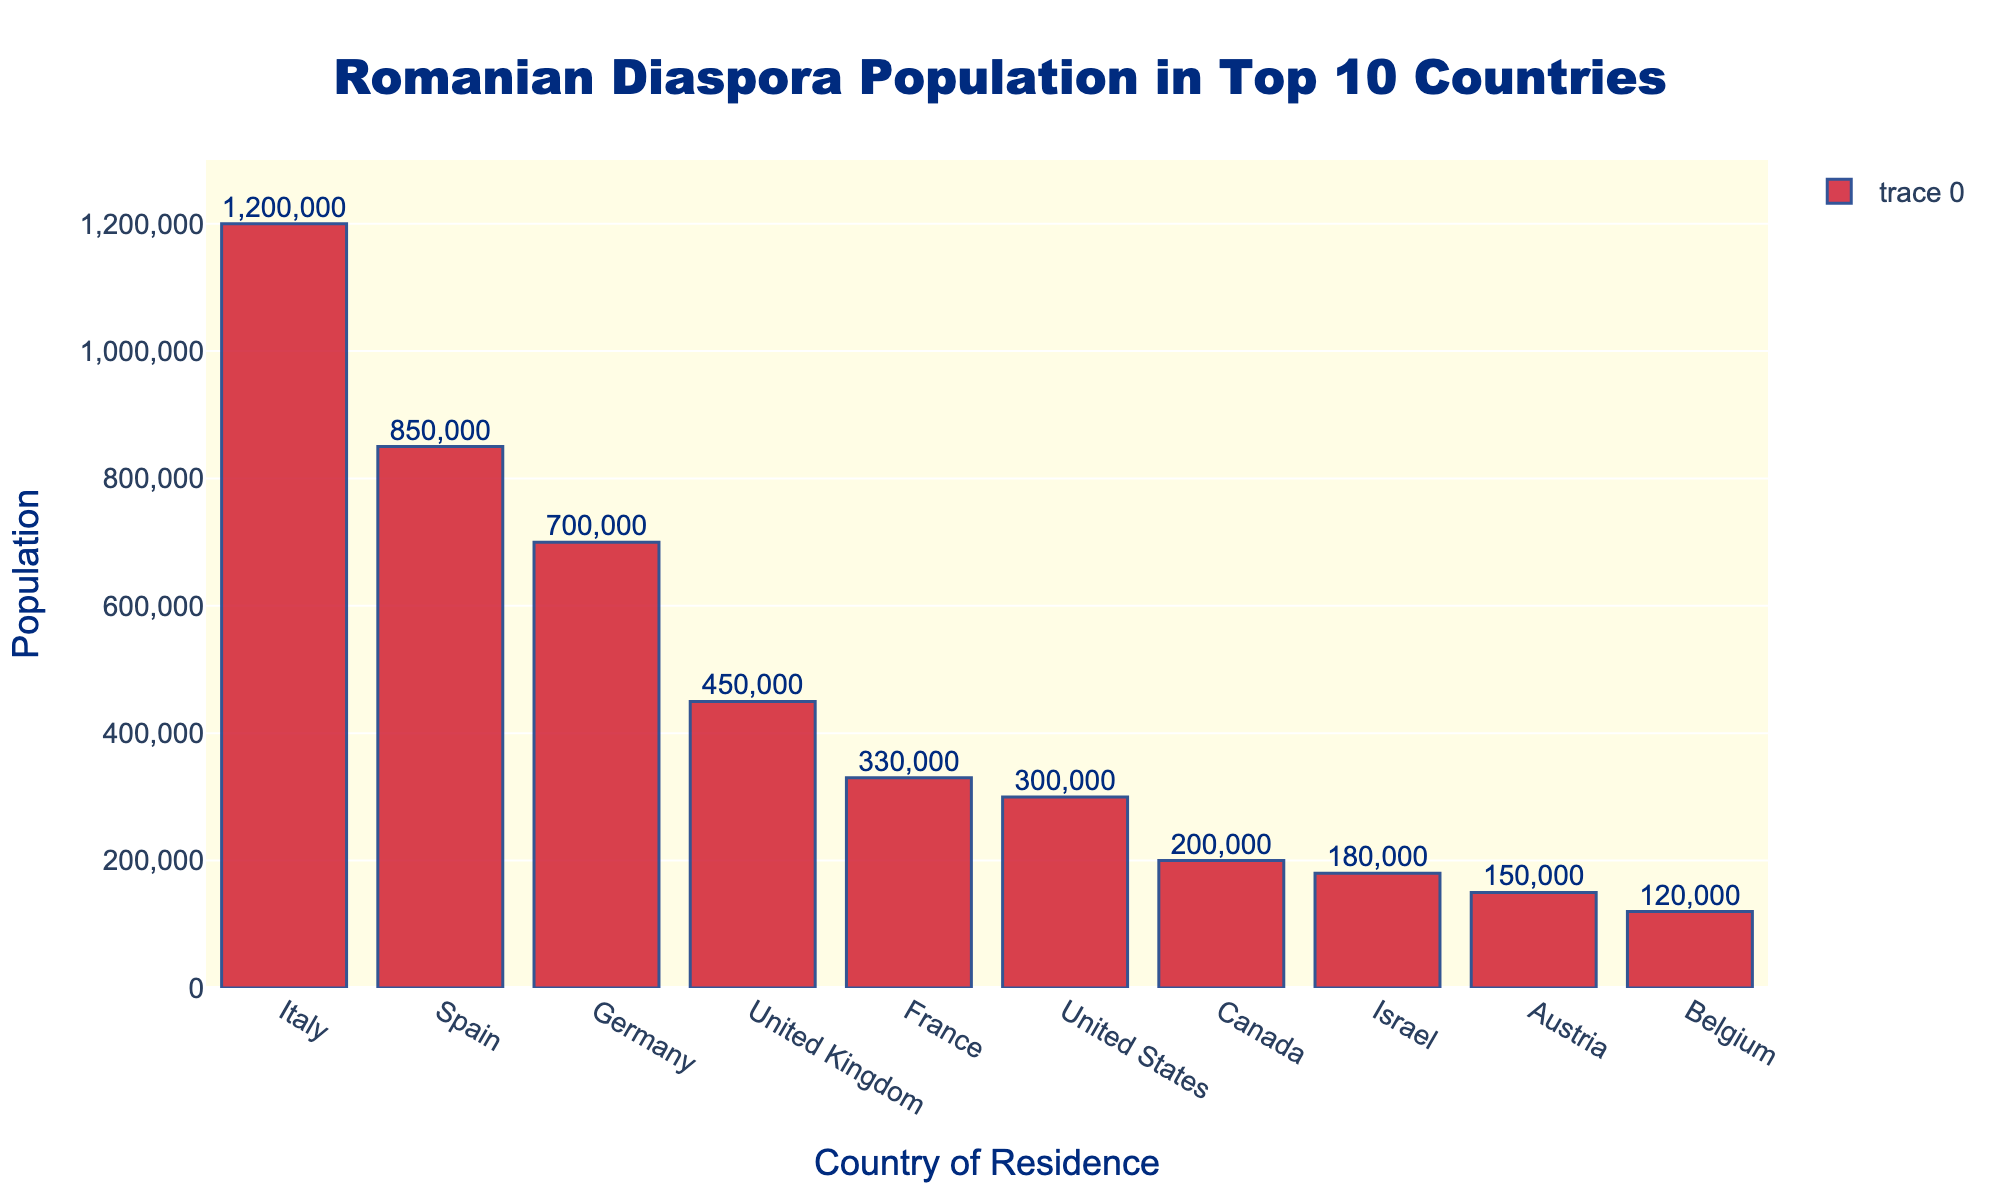What is the total Romanian diaspora population across the top 10 countries? Add up the Romanian populations in all the listed countries: 1,200,000 (Italy) + 850,000 (Spain) + 700,000 (Germany) + 450,000 (United Kingdom) + 330,000 (France) + 300,000 (United States) + 200,000 (Canada) + 180,000 (Israel) + 150,000 (Austria) + 120,000 (Belgium). The total is 1200000 + 850000 + 700000 + 450000 + 330000 + 300000 + 200000 + 180000 + 150000 + 120000 = 4,480,000
Answer: 4,480,000 Which country has the highest Romanian diaspora population? Look at the bar with the greatest height and label; it is associated with Italy, which has a population of 1,200,000.
Answer: Italy How does the Romanian diaspora population in Germany compare to that in Spain? Check the populations for both Germany and Spain. Spain has 850,000 while Germany has 700,000. Spain has a higher Romanian population than Germany.
Answer: Spain is higher What is the difference in Romanian population between the United Kingdom and Canada? Subtract the Romanian population in Canada from that in the United Kingdom: 450,000 (United Kingdom) - 200,000 (Canada) = 450,000 - 200,000 = 250,000.
Answer: 250,000 Which country has the smallest Romanian diaspora population among the top 10 listed countries? Identify the bar with the smallest height; it corresponds to Belgium, which has a population of 120,000.
Answer: Belgium What is the average Romanian diaspora population in these top 10 countries? Calculate the average by adding all the populations together and then dividing by the number of countries: (1,200,000 + 850,000 + 700,000 + 450,000 + 330,000 + 300,000 + 200,000 + 180,000 + 150,000 + 120,000) / 10 = (4,480,000) / 10 = 448,000.
Answer: 448,000 How many countries have a Romanian diaspora population of over 500,000? Count the countries with a population greater than 500,000. Italy, Spain, and Germany each have more than 500,000. This makes a total of 3 countries.
Answer: 3 What is the combined Romanian population in France and Israel? Sum the Romanian populations in France and Israel: 330,000 (France) + 180,000 (Israel) = 330,000 + 180,000 = 510,000.
Answer: 510,000 Which country has a larger Romanian diaspora population: France or United States? Compare the heights of the bars for France and the United States. France has 330,000 and United States has 300,000. France has a larger population.
Answer: France Is the Romanian diaspora population in Italy more than double that in the United States? Compare twice the population in the United States (2 * 300,000 = 600,000) to that in Italy (1,200,000). Italy's population (1,200,000) is indeed more than double.
Answer: Yes 